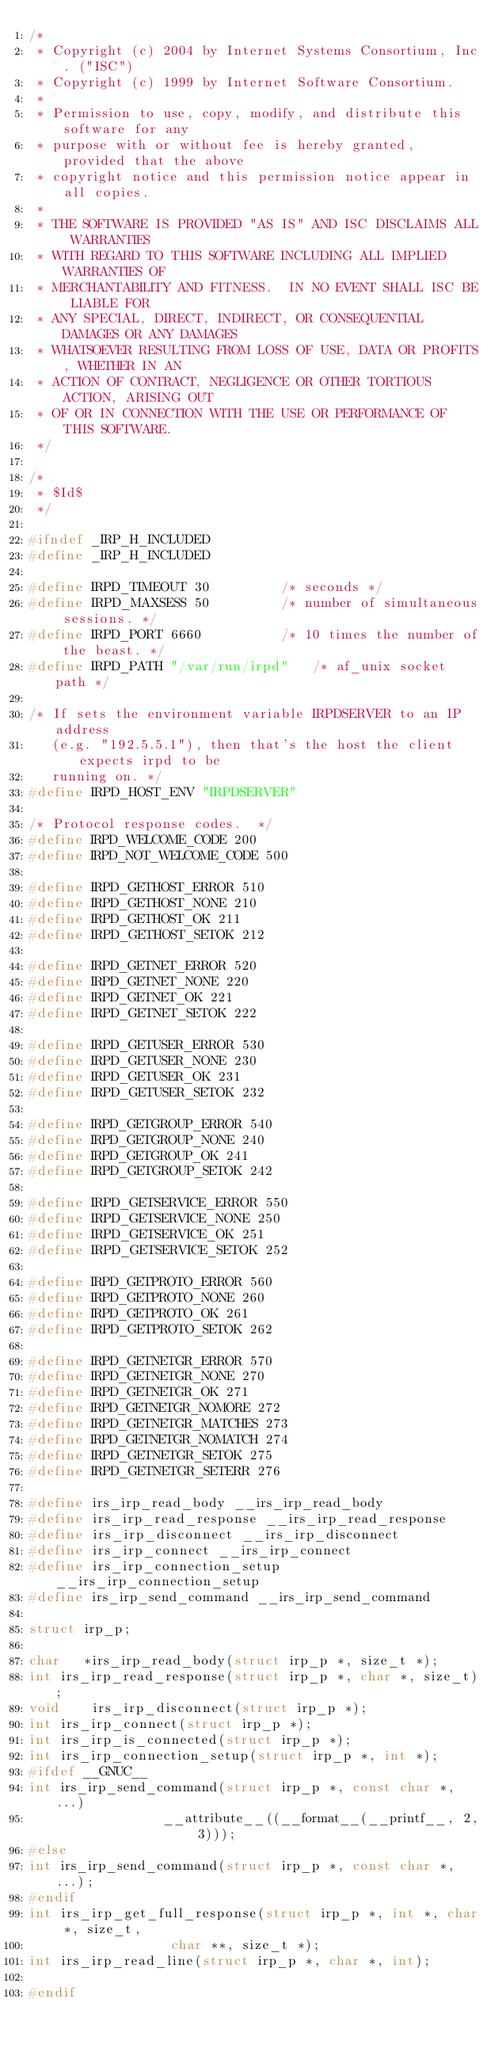Convert code to text. <code><loc_0><loc_0><loc_500><loc_500><_C_>/*
 * Copyright (c) 2004 by Internet Systems Consortium, Inc. ("ISC")
 * Copyright (c) 1999 by Internet Software Consortium.
 *
 * Permission to use, copy, modify, and distribute this software for any
 * purpose with or without fee is hereby granted, provided that the above
 * copyright notice and this permission notice appear in all copies.
 *
 * THE SOFTWARE IS PROVIDED "AS IS" AND ISC DISCLAIMS ALL WARRANTIES
 * WITH REGARD TO THIS SOFTWARE INCLUDING ALL IMPLIED WARRANTIES OF
 * MERCHANTABILITY AND FITNESS.  IN NO EVENT SHALL ISC BE LIABLE FOR
 * ANY SPECIAL, DIRECT, INDIRECT, OR CONSEQUENTIAL DAMAGES OR ANY DAMAGES
 * WHATSOEVER RESULTING FROM LOSS OF USE, DATA OR PROFITS, WHETHER IN AN
 * ACTION OF CONTRACT, NEGLIGENCE OR OTHER TORTIOUS ACTION, ARISING OUT
 * OF OR IN CONNECTION WITH THE USE OR PERFORMANCE OF THIS SOFTWARE.
 */

/*
 * $Id$
 */

#ifndef _IRP_H_INCLUDED
#define _IRP_H_INCLUDED

#define IRPD_TIMEOUT 30			/* seconds */
#define IRPD_MAXSESS 50			/* number of simultaneous sessions. */
#define IRPD_PORT 6660			/* 10 times the number of the beast. */
#define IRPD_PATH "/var/run/irpd"	/* af_unix socket path */

/* If sets the environment variable IRPDSERVER to an IP address
   (e.g. "192.5.5.1"), then that's the host the client expects irpd to be
   running on. */
#define IRPD_HOST_ENV "IRPDSERVER"

/* Protocol response codes.  */
#define IRPD_WELCOME_CODE 200
#define IRPD_NOT_WELCOME_CODE 500

#define IRPD_GETHOST_ERROR 510
#define IRPD_GETHOST_NONE 210
#define IRPD_GETHOST_OK 211
#define IRPD_GETHOST_SETOK 212

#define IRPD_GETNET_ERROR 520
#define IRPD_GETNET_NONE 220
#define IRPD_GETNET_OK 221
#define IRPD_GETNET_SETOK 222

#define IRPD_GETUSER_ERROR 530
#define IRPD_GETUSER_NONE 230
#define IRPD_GETUSER_OK 231
#define IRPD_GETUSER_SETOK 232

#define IRPD_GETGROUP_ERROR 540
#define IRPD_GETGROUP_NONE 240
#define IRPD_GETGROUP_OK 241
#define IRPD_GETGROUP_SETOK 242

#define IRPD_GETSERVICE_ERROR 550
#define IRPD_GETSERVICE_NONE 250
#define IRPD_GETSERVICE_OK 251
#define IRPD_GETSERVICE_SETOK 252

#define IRPD_GETPROTO_ERROR 560
#define IRPD_GETPROTO_NONE 260
#define IRPD_GETPROTO_OK 261
#define IRPD_GETPROTO_SETOK 262

#define IRPD_GETNETGR_ERROR 570
#define IRPD_GETNETGR_NONE 270
#define IRPD_GETNETGR_OK 271
#define IRPD_GETNETGR_NOMORE 272
#define IRPD_GETNETGR_MATCHES 273
#define IRPD_GETNETGR_NOMATCH 274
#define IRPD_GETNETGR_SETOK 275
#define IRPD_GETNETGR_SETERR 276

#define	irs_irp_read_body __irs_irp_read_body
#define irs_irp_read_response __irs_irp_read_response
#define irs_irp_disconnect __irs_irp_disconnect
#define irs_irp_connect __irs_irp_connect
#define irs_irp_connection_setup __irs_irp_connection_setup
#define irs_irp_send_command __irs_irp_send_command

struct irp_p;

char   *irs_irp_read_body(struct irp_p *, size_t *);
int	irs_irp_read_response(struct irp_p *, char *, size_t);
void	irs_irp_disconnect(struct irp_p *);
int	irs_irp_connect(struct irp_p *);
int	irs_irp_is_connected(struct irp_p *);
int	irs_irp_connection_setup(struct irp_p *, int *);
#ifdef __GNUC__
int	irs_irp_send_command(struct irp_p *, const char *, ...)
			     __attribute__((__format__(__printf__, 2, 3)));
#else
int	irs_irp_send_command(struct irp_p *, const char *, ...);
#endif
int	irs_irp_get_full_response(struct irp_p *, int *, char *, size_t,
				  char **, size_t *);
int	irs_irp_read_line(struct irp_p *, char *, int);

#endif
</code> 